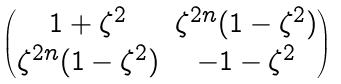Convert formula to latex. <formula><loc_0><loc_0><loc_500><loc_500>\begin{pmatrix} 1 + \zeta ^ { 2 } & \zeta ^ { 2 n } ( 1 - \zeta ^ { 2 } ) \\ \zeta ^ { 2 n } ( 1 - \zeta ^ { 2 } ) & - 1 - \zeta ^ { 2 } \end{pmatrix}</formula> 